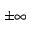Convert formula to latex. <formula><loc_0><loc_0><loc_500><loc_500>\pm \infty</formula> 